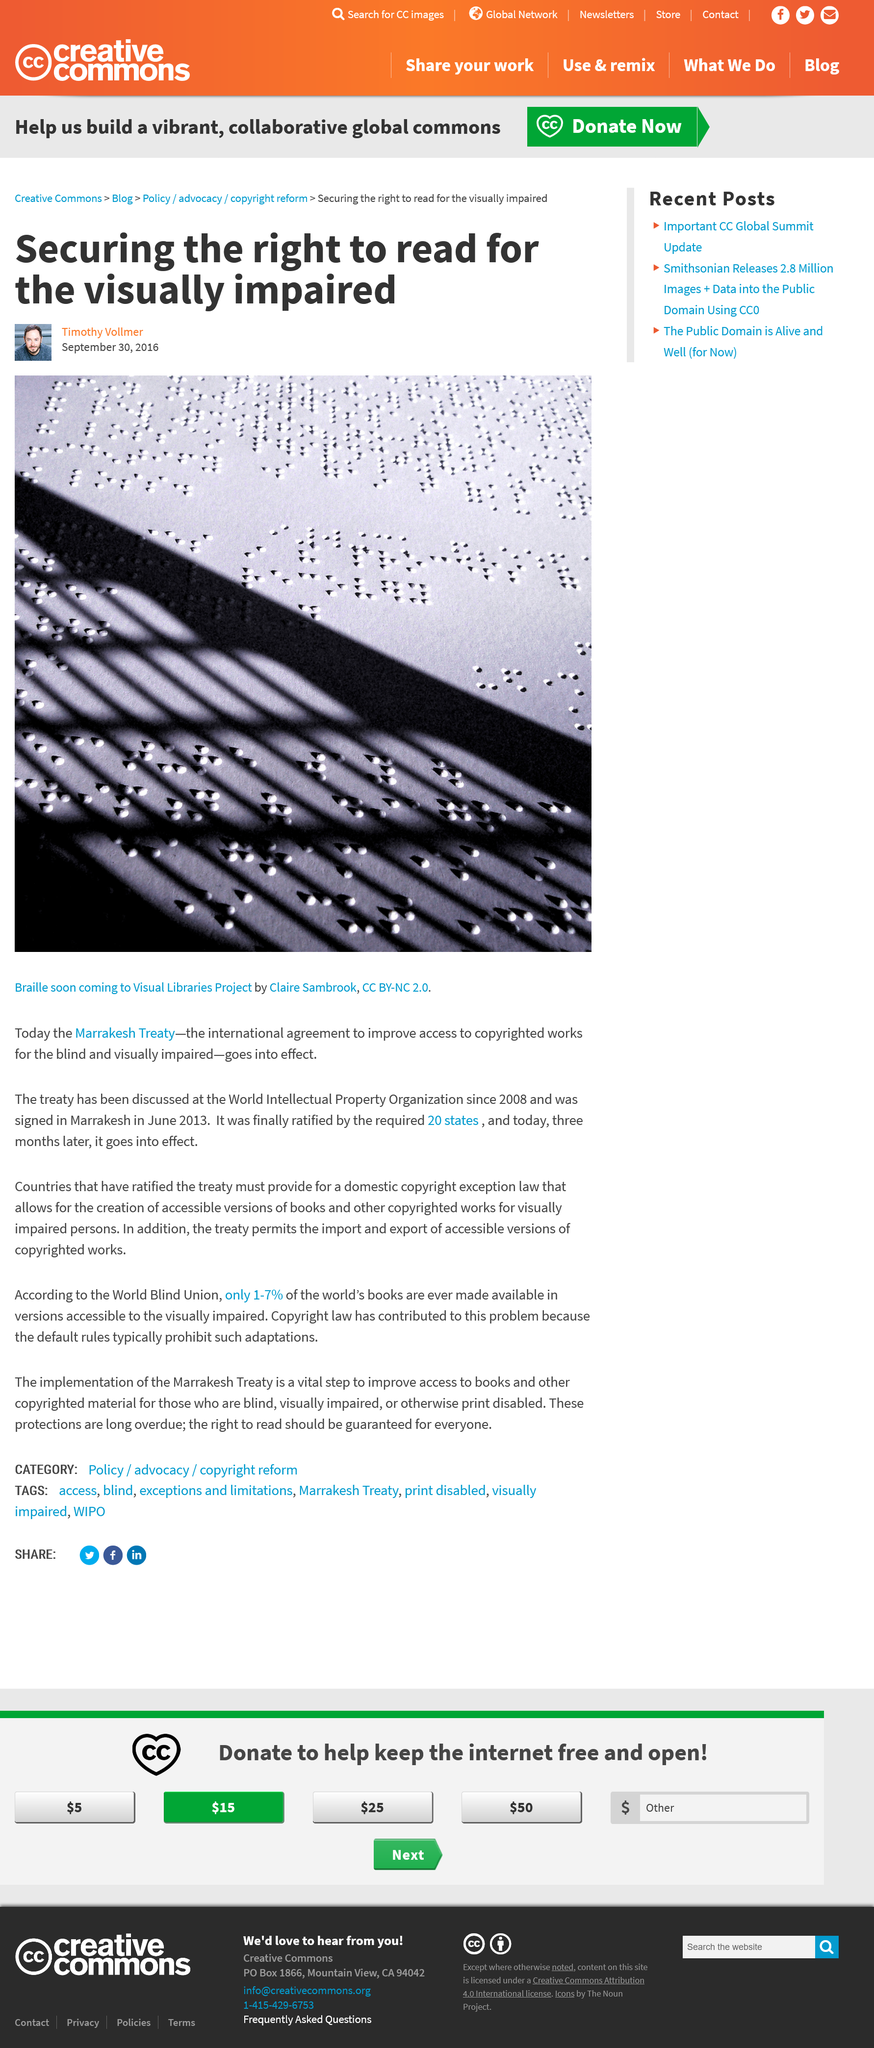List a handful of essential elements in this visual. The Marrakesh Treaty has been the subject of discussions at the World Intellectual Property Organization. The Marrakesh Treaty went into effect in September 2013. The Marrakesh Treaty is the name of the treaty mentioned in the article. 